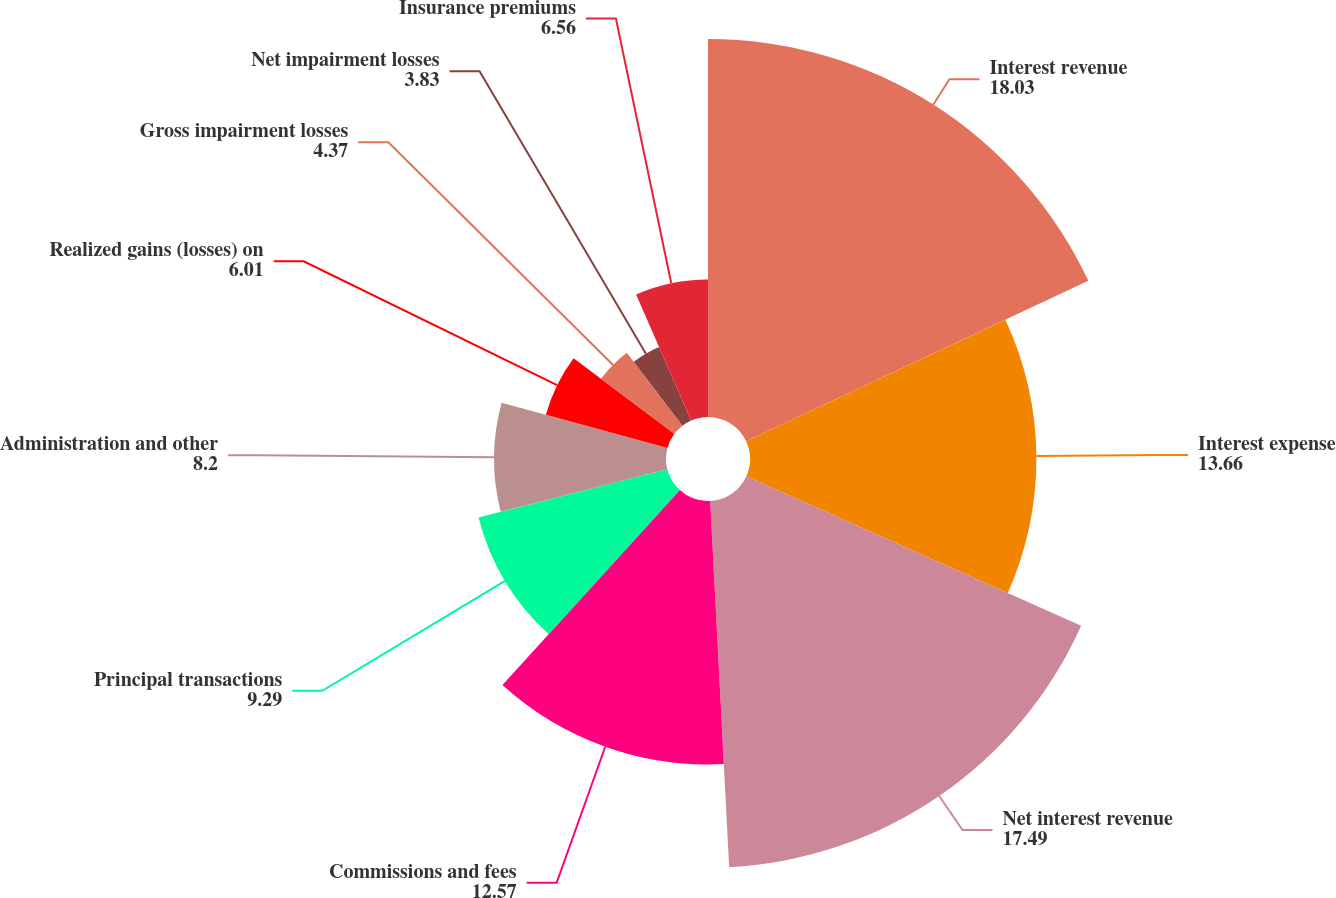Convert chart to OTSL. <chart><loc_0><loc_0><loc_500><loc_500><pie_chart><fcel>Interest revenue<fcel>Interest expense<fcel>Net interest revenue<fcel>Commissions and fees<fcel>Principal transactions<fcel>Administration and other<fcel>Realized gains (losses) on<fcel>Gross impairment losses<fcel>Net impairment losses<fcel>Insurance premiums<nl><fcel>18.03%<fcel>13.66%<fcel>17.49%<fcel>12.57%<fcel>9.29%<fcel>8.2%<fcel>6.01%<fcel>4.37%<fcel>3.83%<fcel>6.56%<nl></chart> 